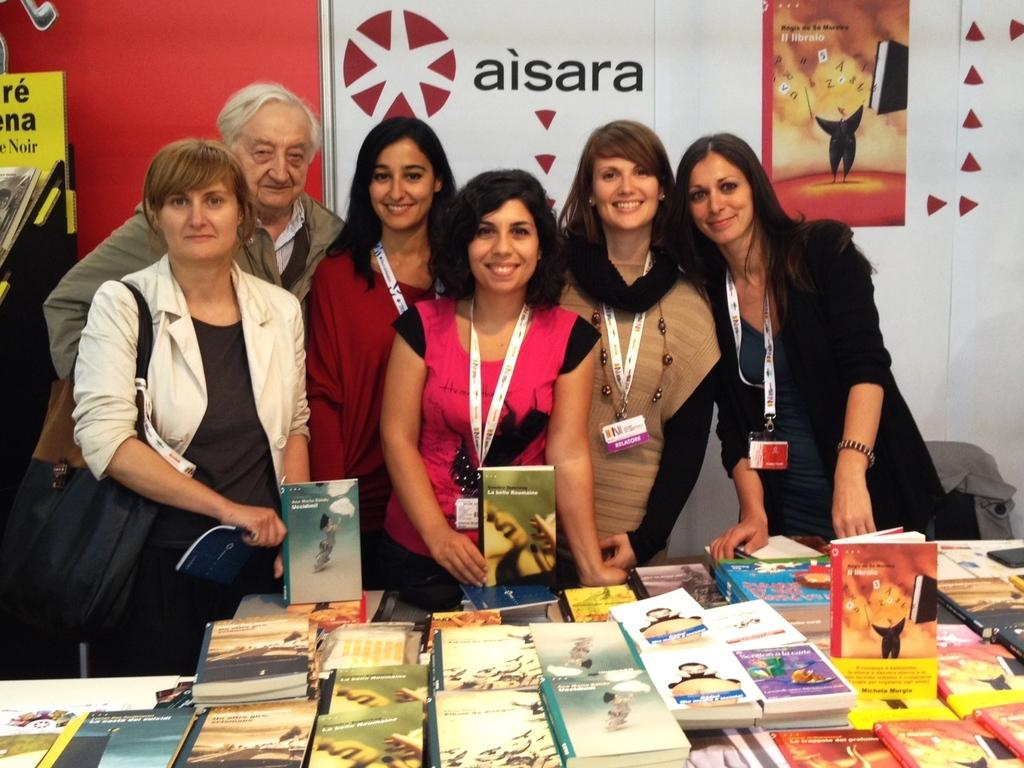<image>
Write a terse but informative summary of the picture. some people standing in front of an aisara sign 